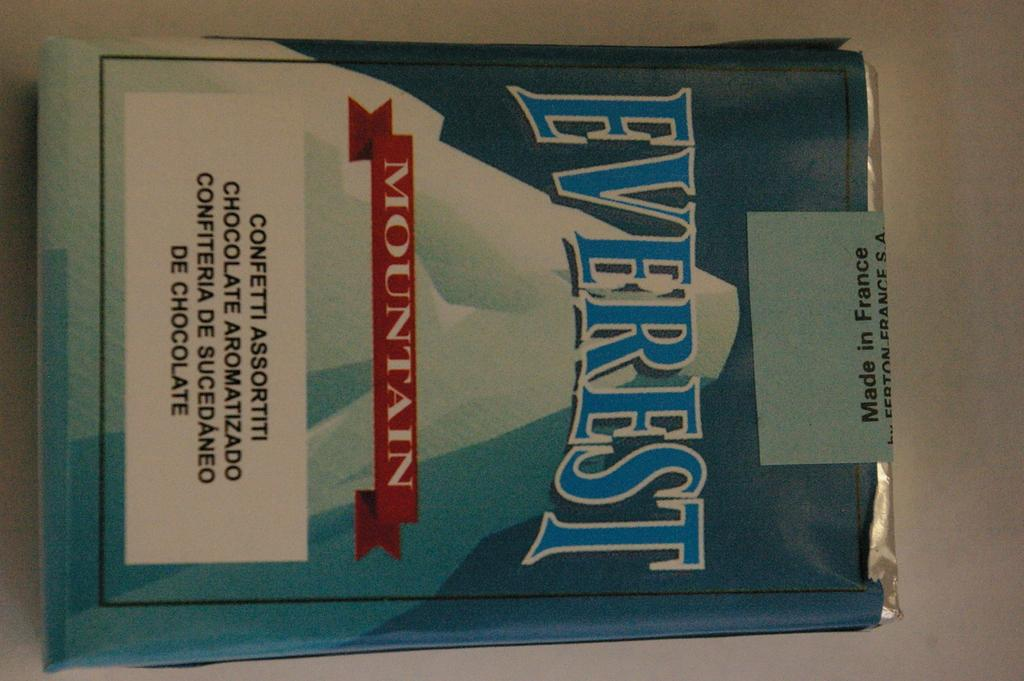<image>
Relay a brief, clear account of the picture shown. A package has an Everest logo and a mountain on it. 